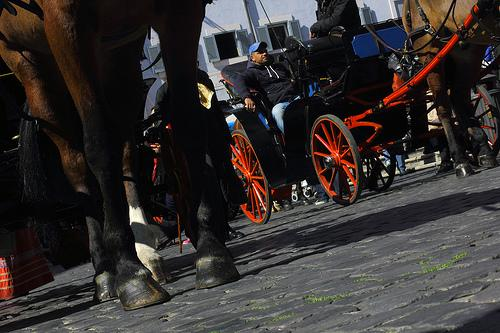Count the number of horses in the image and describe one of their features. There are two horses in the image, one of them has a white leg and hoof between a set of black legs. Assess the quality of the image in terms of sharpness and focus on the subjects. The image has good quality, showing sharp focus and clear details of the subjects like the man in the carriage and the horses. Point out the location and color of two windows on a building in the image. There are two black windows located on the side of a grey building. What type of vehicle is in the image and how is it being transported? There is a horse-drawn carriage in the image, and a brown horse is pulling it on a brick pavement. Explain the appearance of the carriage's wheels and the material they are made of. The carriage has red wooden wagon wheels with black tires, creating a contrasting color combination. Mention what the man wearing blue jeans is doing and what else he's wearing in the image. The man wearing blue jeans is sitting in a carriage, also wearing a blue baseball cap and a black sweatshirt with a hood. Describe the surface where the horse and carriage are positioned and any additional detail about it. The horse and carriage are on a cobblestone pathway with some grass growing through the grey brick pavement. Explain any interaction observed between a horse and carriage part in the image. A brown horse is pulling an orange and black carriage, connected by red hook up for the horse. What type of clothing item is black with white drawstrings in the image? A black sweatshirt with white drawstrings and a hood is captured in the image. Identify the type of hat the man in the carriage is wearing and the color of the horse pulling the carriage. The man in the carriage is wearing a blue baseball cap, and the horse pulling the carriage is brown. Is there a black and white carriage a horse is pulling? The image has an orange and black carriage a horse is pulling, not a black and white one. Can you find a green baseball cap on a man's head? There is a blue baseball cap on a man's head, not a green one. Can you point out a grey horse pulling a carriage? The image has a brown horse pulling a blue carriage, not a grey one. Are there three black windows on each side of a man in a blue hat's head? The image has two black windows on each side of a man in a blue hat's head, not three. Is there a yellow horse leg and hoof between a set of black legs? The image has a white horse leg and hoof between a set of black legs, not a yellow one. Can you see a person wearing a red jacket in the carriage? The image has a man wearing a black jacket, not a red one. 